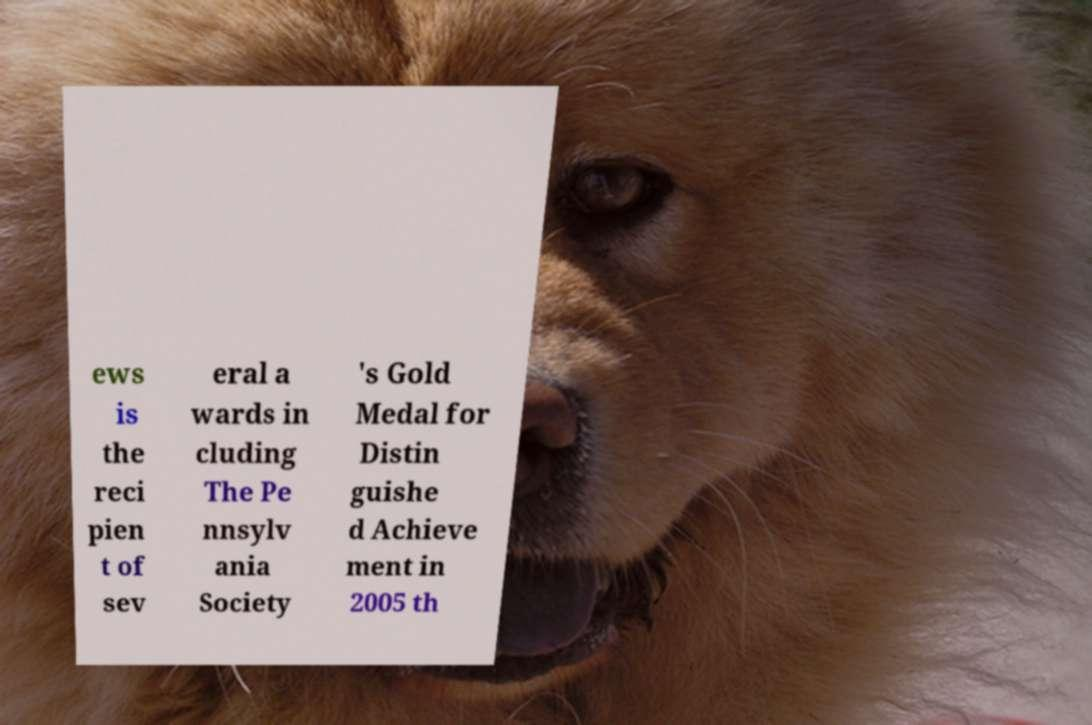For documentation purposes, I need the text within this image transcribed. Could you provide that? ews is the reci pien t of sev eral a wards in cluding The Pe nnsylv ania Society 's Gold Medal for Distin guishe d Achieve ment in 2005 th 